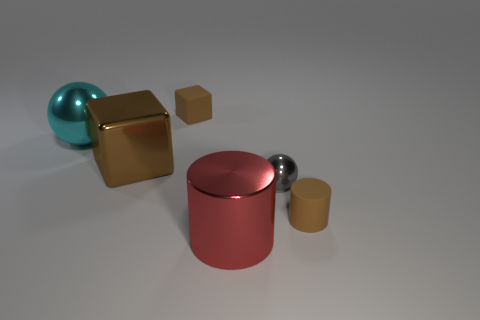Add 3 tiny brown cylinders. How many objects exist? 9 Subtract all spheres. How many objects are left? 4 Subtract 1 brown cylinders. How many objects are left? 5 Subtract all big red metallic objects. Subtract all large objects. How many objects are left? 2 Add 3 metallic spheres. How many metallic spheres are left? 5 Add 1 green rubber objects. How many green rubber objects exist? 1 